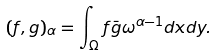Convert formula to latex. <formula><loc_0><loc_0><loc_500><loc_500>( f , g ) _ { \alpha } = \int _ { \Omega } f \bar { g } \omega ^ { \alpha - 1 } d x d y .</formula> 